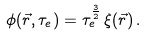Convert formula to latex. <formula><loc_0><loc_0><loc_500><loc_500>\phi ( \vec { r } , \tau _ { e } ) = \tau _ { e } ^ { \frac { 3 } { 2 } } \, \xi ( \vec { r } ) \, .</formula> 